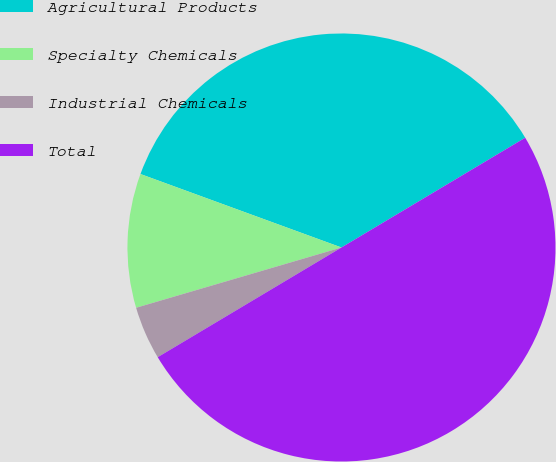Convert chart. <chart><loc_0><loc_0><loc_500><loc_500><pie_chart><fcel>Agricultural Products<fcel>Specialty Chemicals<fcel>Industrial Chemicals<fcel>Total<nl><fcel>35.85%<fcel>10.12%<fcel>4.02%<fcel>50.0%<nl></chart> 